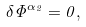<formula> <loc_0><loc_0><loc_500><loc_500>\delta \Phi ^ { \alpha _ { 2 } } = 0 ,</formula> 